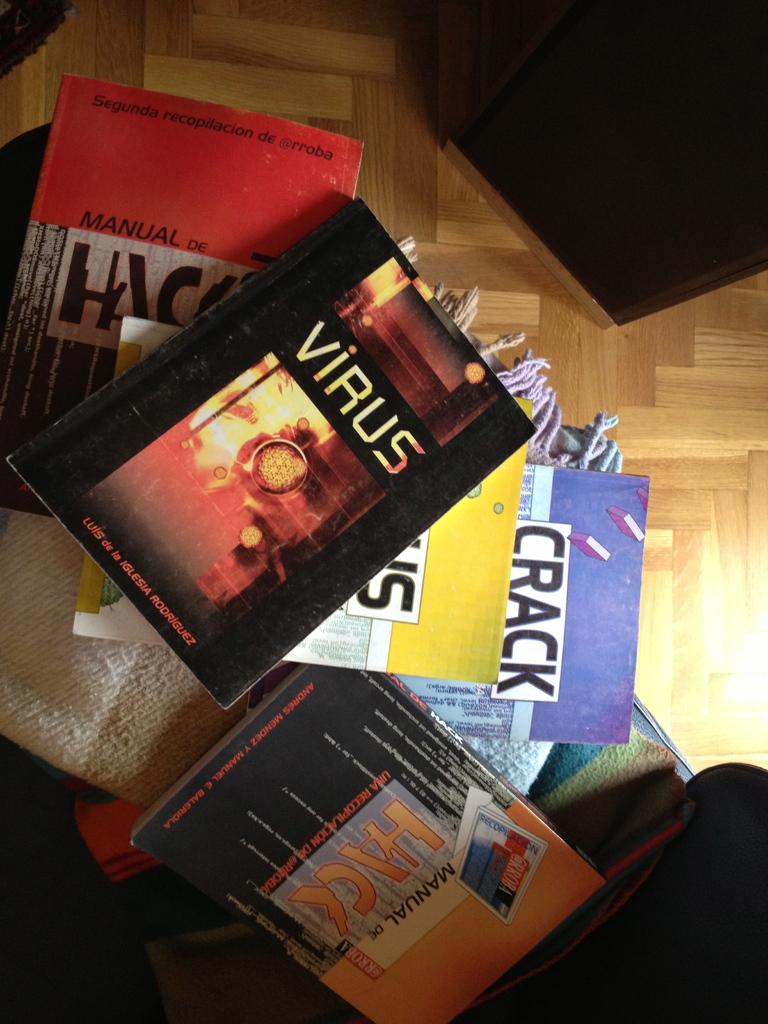What is the best book written on computer viruses in 21st century?
Offer a very short reply. Unanswerable. What is the title of the top book?
Provide a succinct answer. Virus. 